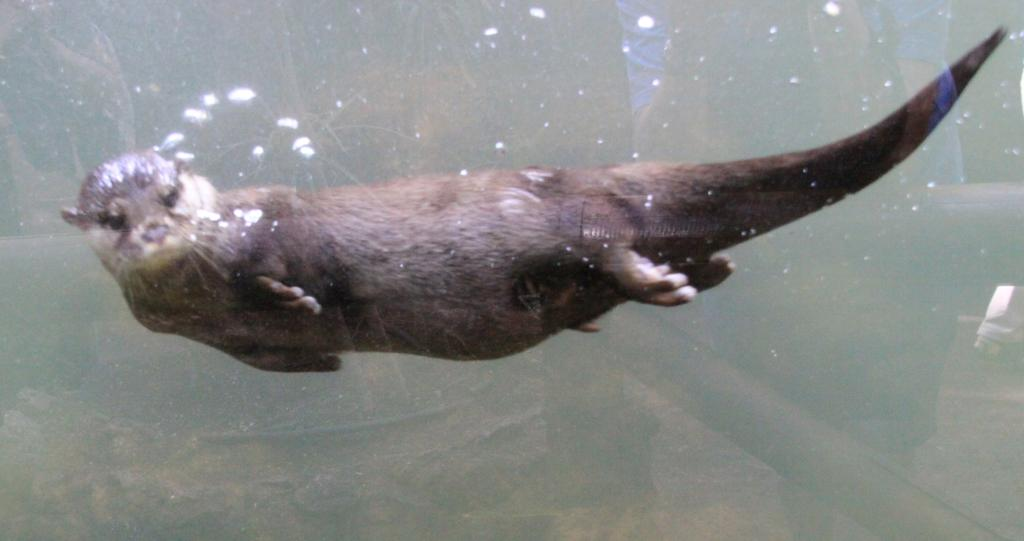What animal is present in the image? There is a seal in the image. What is the seal doing in the image? The seal is swimming in the water. How many goldfish are swimming with the seal in the image? There are no goldfish present in the image; it only features a seal swimming in the water. What is the seal's daughter doing in the image? There is no mention of a daughter or any other seal in the image; it only features a single seal swimming. 